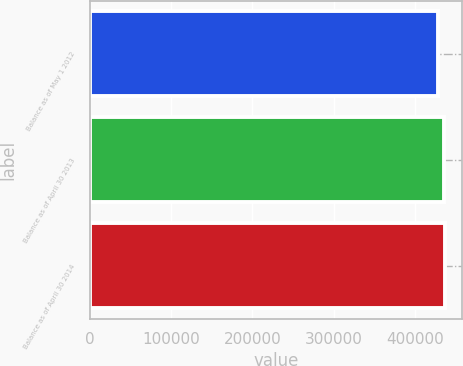Convert chart to OTSL. <chart><loc_0><loc_0><loc_500><loc_500><bar_chart><fcel>Balance as of May 1 2012<fcel>Balance as of April 30 2013<fcel>Balance as of April 30 2014<nl><fcel>427566<fcel>434782<fcel>436117<nl></chart> 